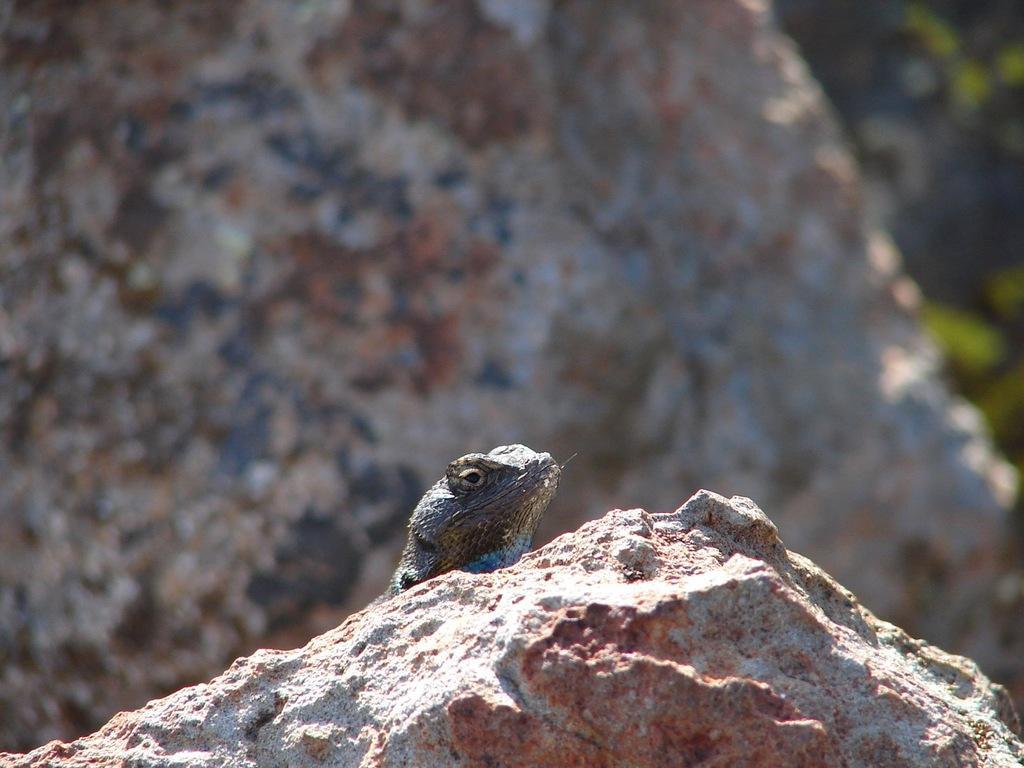Please provide a concise description of this image. In this image there is a reptile on a rock. Behind it there is another rock. To the right there are leaves of a plant. 